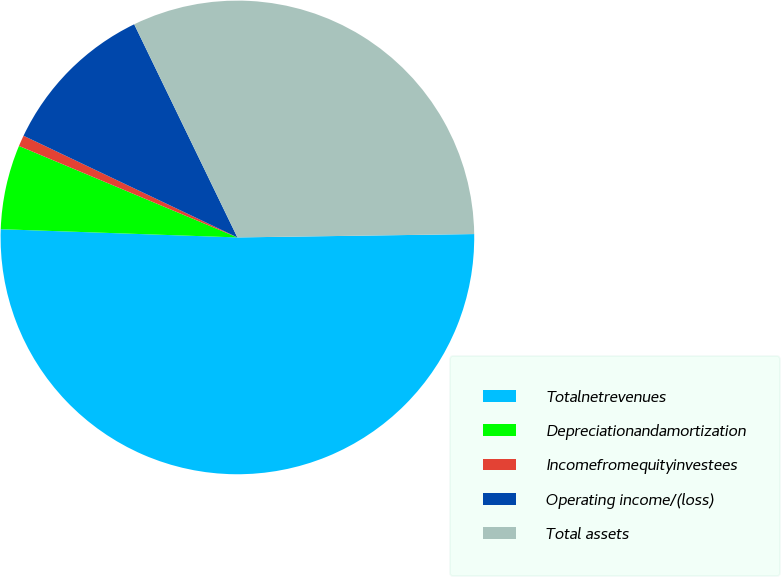<chart> <loc_0><loc_0><loc_500><loc_500><pie_chart><fcel>Totalnetrevenues<fcel>Depreciationandamortization<fcel>Incomefromequityinvestees<fcel>Operating income/(loss)<fcel>Total assets<nl><fcel>50.78%<fcel>5.76%<fcel>0.75%<fcel>10.76%<fcel>31.95%<nl></chart> 